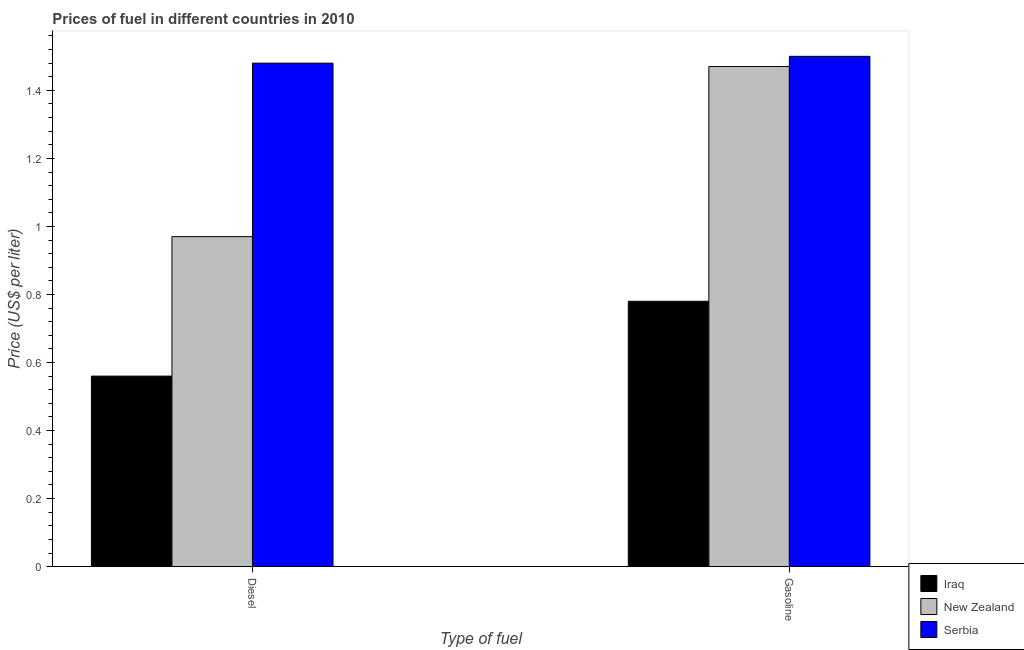How many different coloured bars are there?
Give a very brief answer. 3. How many groups of bars are there?
Provide a succinct answer. 2. Are the number of bars per tick equal to the number of legend labels?
Ensure brevity in your answer.  Yes. Are the number of bars on each tick of the X-axis equal?
Offer a very short reply. Yes. How many bars are there on the 2nd tick from the left?
Make the answer very short. 3. What is the label of the 1st group of bars from the left?
Give a very brief answer. Diesel. What is the diesel price in Iraq?
Offer a terse response. 0.56. Across all countries, what is the maximum diesel price?
Your answer should be very brief. 1.48. Across all countries, what is the minimum gasoline price?
Offer a very short reply. 0.78. In which country was the diesel price maximum?
Your answer should be compact. Serbia. In which country was the gasoline price minimum?
Your answer should be compact. Iraq. What is the total diesel price in the graph?
Keep it short and to the point. 3.01. What is the difference between the diesel price in Serbia and that in Iraq?
Your answer should be compact. 0.92. What is the difference between the diesel price in Iraq and the gasoline price in Serbia?
Make the answer very short. -0.94. What is the average diesel price per country?
Offer a very short reply. 1. What is the difference between the gasoline price and diesel price in New Zealand?
Give a very brief answer. 0.5. What is the ratio of the gasoline price in New Zealand to that in Iraq?
Give a very brief answer. 1.88. Is the gasoline price in New Zealand less than that in Serbia?
Offer a terse response. Yes. What does the 1st bar from the left in Diesel represents?
Keep it short and to the point. Iraq. What does the 3rd bar from the right in Gasoline represents?
Keep it short and to the point. Iraq. How many bars are there?
Provide a succinct answer. 6. Are all the bars in the graph horizontal?
Your response must be concise. No. How many countries are there in the graph?
Give a very brief answer. 3. What is the difference between two consecutive major ticks on the Y-axis?
Give a very brief answer. 0.2. Does the graph contain grids?
Give a very brief answer. No. How many legend labels are there?
Your response must be concise. 3. What is the title of the graph?
Ensure brevity in your answer.  Prices of fuel in different countries in 2010. What is the label or title of the X-axis?
Your response must be concise. Type of fuel. What is the label or title of the Y-axis?
Offer a very short reply. Price (US$ per liter). What is the Price (US$ per liter) of Iraq in Diesel?
Provide a short and direct response. 0.56. What is the Price (US$ per liter) of Serbia in Diesel?
Give a very brief answer. 1.48. What is the Price (US$ per liter) in Iraq in Gasoline?
Keep it short and to the point. 0.78. What is the Price (US$ per liter) of New Zealand in Gasoline?
Provide a succinct answer. 1.47. Across all Type of fuel, what is the maximum Price (US$ per liter) in Iraq?
Ensure brevity in your answer.  0.78. Across all Type of fuel, what is the maximum Price (US$ per liter) of New Zealand?
Provide a succinct answer. 1.47. Across all Type of fuel, what is the minimum Price (US$ per liter) of Iraq?
Your response must be concise. 0.56. Across all Type of fuel, what is the minimum Price (US$ per liter) of Serbia?
Offer a very short reply. 1.48. What is the total Price (US$ per liter) of Iraq in the graph?
Provide a short and direct response. 1.34. What is the total Price (US$ per liter) in New Zealand in the graph?
Provide a short and direct response. 2.44. What is the total Price (US$ per liter) in Serbia in the graph?
Offer a very short reply. 2.98. What is the difference between the Price (US$ per liter) of Iraq in Diesel and that in Gasoline?
Your answer should be compact. -0.22. What is the difference between the Price (US$ per liter) of New Zealand in Diesel and that in Gasoline?
Provide a succinct answer. -0.5. What is the difference between the Price (US$ per liter) of Serbia in Diesel and that in Gasoline?
Give a very brief answer. -0.02. What is the difference between the Price (US$ per liter) of Iraq in Diesel and the Price (US$ per liter) of New Zealand in Gasoline?
Your answer should be very brief. -0.91. What is the difference between the Price (US$ per liter) of Iraq in Diesel and the Price (US$ per liter) of Serbia in Gasoline?
Keep it short and to the point. -0.94. What is the difference between the Price (US$ per liter) of New Zealand in Diesel and the Price (US$ per liter) of Serbia in Gasoline?
Give a very brief answer. -0.53. What is the average Price (US$ per liter) of Iraq per Type of fuel?
Your response must be concise. 0.67. What is the average Price (US$ per liter) in New Zealand per Type of fuel?
Offer a very short reply. 1.22. What is the average Price (US$ per liter) of Serbia per Type of fuel?
Your answer should be compact. 1.49. What is the difference between the Price (US$ per liter) in Iraq and Price (US$ per liter) in New Zealand in Diesel?
Offer a terse response. -0.41. What is the difference between the Price (US$ per liter) in Iraq and Price (US$ per liter) in Serbia in Diesel?
Your answer should be very brief. -0.92. What is the difference between the Price (US$ per liter) of New Zealand and Price (US$ per liter) of Serbia in Diesel?
Give a very brief answer. -0.51. What is the difference between the Price (US$ per liter) of Iraq and Price (US$ per liter) of New Zealand in Gasoline?
Provide a short and direct response. -0.69. What is the difference between the Price (US$ per liter) of Iraq and Price (US$ per liter) of Serbia in Gasoline?
Your answer should be compact. -0.72. What is the difference between the Price (US$ per liter) in New Zealand and Price (US$ per liter) in Serbia in Gasoline?
Provide a succinct answer. -0.03. What is the ratio of the Price (US$ per liter) of Iraq in Diesel to that in Gasoline?
Your answer should be very brief. 0.72. What is the ratio of the Price (US$ per liter) in New Zealand in Diesel to that in Gasoline?
Your answer should be compact. 0.66. What is the ratio of the Price (US$ per liter) in Serbia in Diesel to that in Gasoline?
Ensure brevity in your answer.  0.99. What is the difference between the highest and the second highest Price (US$ per liter) of Iraq?
Make the answer very short. 0.22. What is the difference between the highest and the second highest Price (US$ per liter) in New Zealand?
Offer a terse response. 0.5. What is the difference between the highest and the second highest Price (US$ per liter) in Serbia?
Provide a short and direct response. 0.02. What is the difference between the highest and the lowest Price (US$ per liter) in Iraq?
Provide a short and direct response. 0.22. What is the difference between the highest and the lowest Price (US$ per liter) of New Zealand?
Make the answer very short. 0.5. What is the difference between the highest and the lowest Price (US$ per liter) in Serbia?
Your answer should be very brief. 0.02. 